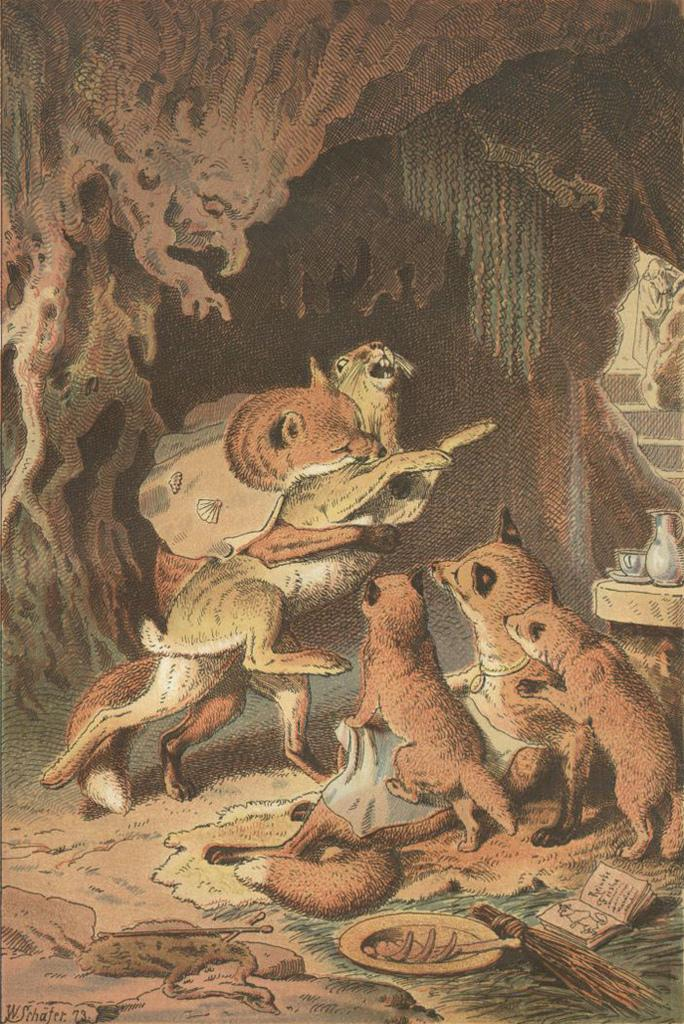What is the main subject of the painting? The painting depicts a group of animals in a cave. What objects can be seen in the painting besides the animals? There is a broomstick, a book, and a plate with food in the painting. How far away is the blood from the animals in the painting? There is no blood present in the painting; it only depicts a group of animals, a broomstick, a book, and a plate with food. 